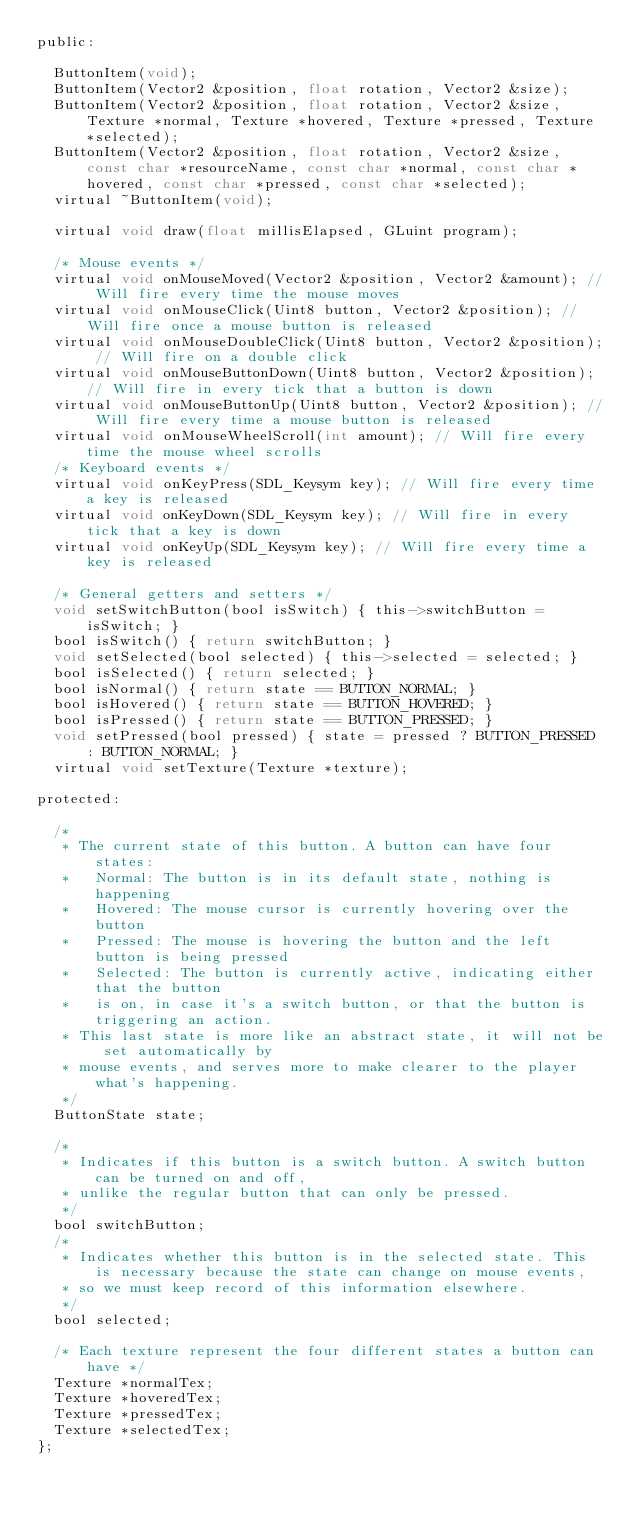<code> <loc_0><loc_0><loc_500><loc_500><_C_>public:

	ButtonItem(void);
	ButtonItem(Vector2 &position, float rotation, Vector2 &size);
	ButtonItem(Vector2 &position, float rotation, Vector2 &size, Texture *normal, Texture *hovered, Texture *pressed, Texture *selected);
	ButtonItem(Vector2 &position, float rotation, Vector2 &size, const char *resourceName, const char *normal, const char *hovered, const char *pressed, const char *selected);
	virtual ~ButtonItem(void);

	virtual void draw(float millisElapsed, GLuint program);

	/* Mouse events */
	virtual void onMouseMoved(Vector2 &position, Vector2 &amount); // Will fire every time the mouse moves
	virtual void onMouseClick(Uint8 button, Vector2 &position); // Will fire once a mouse button is released
	virtual void onMouseDoubleClick(Uint8 button, Vector2 &position); // Will fire on a double click
	virtual void onMouseButtonDown(Uint8 button, Vector2 &position); // Will fire in every tick that a button is down
	virtual void onMouseButtonUp(Uint8 button, Vector2 &position); // Will fire every time a mouse button is released
	virtual void onMouseWheelScroll(int amount); // Will fire every time the mouse wheel scrolls
	/* Keyboard events */
	virtual void onKeyPress(SDL_Keysym key); // Will fire every time a key is released
	virtual void onKeyDown(SDL_Keysym key); // Will fire in every tick that a key is down
	virtual void onKeyUp(SDL_Keysym key); // Will fire every time a key is released

	/* General getters and setters */
	void setSwitchButton(bool isSwitch) { this->switchButton = isSwitch; }
	bool isSwitch() { return switchButton; }
	void setSelected(bool selected) { this->selected = selected; }
	bool isSelected() { return selected; }
	bool isNormal() { return state == BUTTON_NORMAL; }
	bool isHovered() { return state == BUTTON_HOVERED; }
	bool isPressed() { return state == BUTTON_PRESSED; }
	void setPressed(bool pressed) { state = pressed ? BUTTON_PRESSED : BUTTON_NORMAL; }
	virtual void setTexture(Texture *texture);

protected:

	/*
	 * The current state of this button. A button can have four states:
	 *   Normal: The button is in its default state, nothing is happening
	 *   Hovered: The mouse cursor is currently hovering over the button
	 *   Pressed: The mouse is hovering the button and the left button is being pressed
	 *   Selected: The button is currently active, indicating either that the button
	 *   is on, in case it's a switch button, or that the button is triggering an action.
	 * This last state is more like an abstract state, it will not be set automatically by
	 * mouse events, and serves more to make clearer to the player what's happening.
	 */
	ButtonState state;

	/*
	 * Indicates if this button is a switch button. A switch button can be turned on and off,
	 * unlike the regular button that can only be pressed.
	 */
	bool switchButton;
	/*
	 * Indicates whether this button is in the selected state. This is necessary because the state can change on mouse events,
	 * so we must keep record of this information elsewhere.
	 */
	bool selected;

	/* Each texture represent the four different states a button can have */
	Texture *normalTex;
	Texture *hoveredTex;
	Texture *pressedTex;
	Texture *selectedTex;
};

</code> 